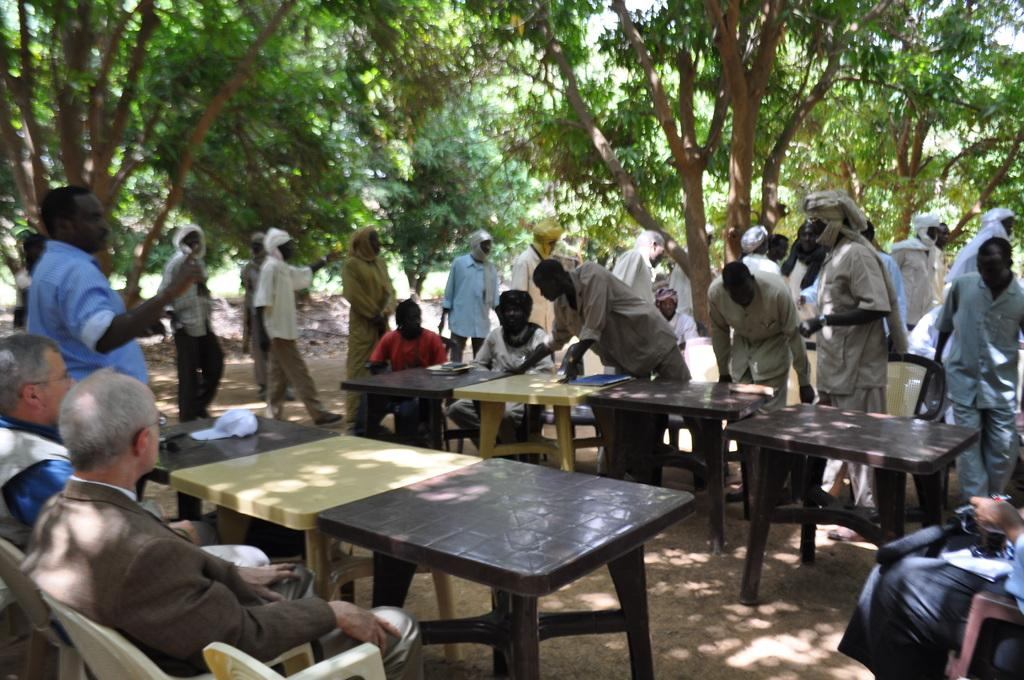What are the people in the image doing? The people in the image are sitting on chairs. Are there any other people in the image besides those sitting on chairs? Yes, there are people standing around the seated people in the image. What objects are in front of the seated people? There are tables in front of the seated people in the image. What can be seen in the background of the image? Trees are visible in the background of the image. What is the value of the sister's painting in the image? There is no mention of a painting or a sister in the image, so it is not possible to determine the value of a painting. 